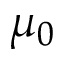Convert formula to latex. <formula><loc_0><loc_0><loc_500><loc_500>\mu _ { 0 }</formula> 